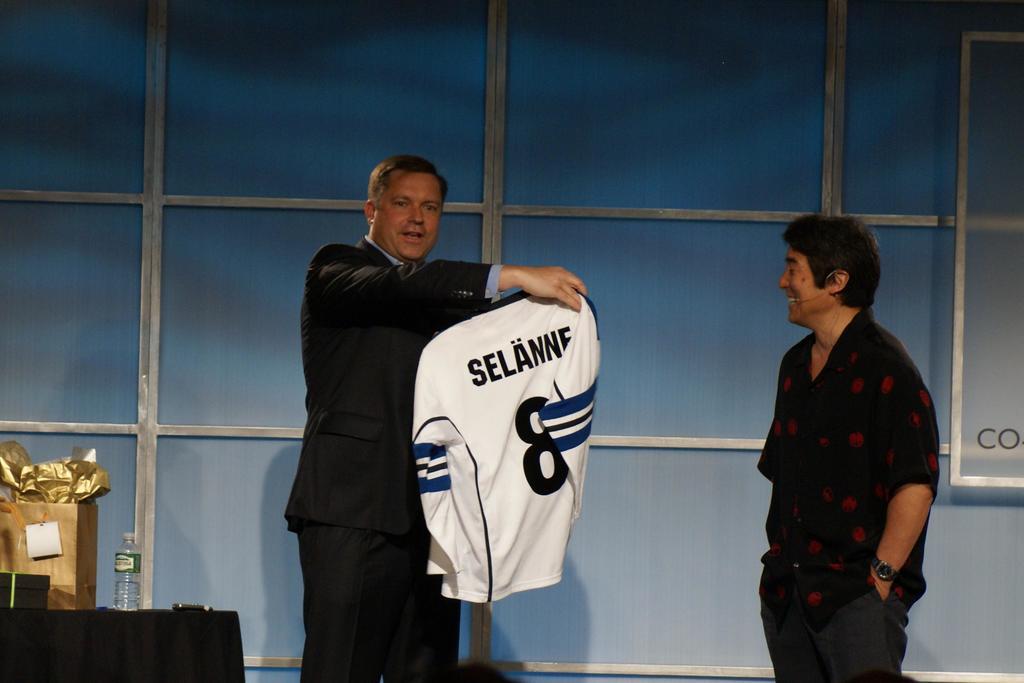What number is on the jersey that the man is displaying?
Your response must be concise. 8. What's the name on the jersey?
Ensure brevity in your answer.  Selanne. 